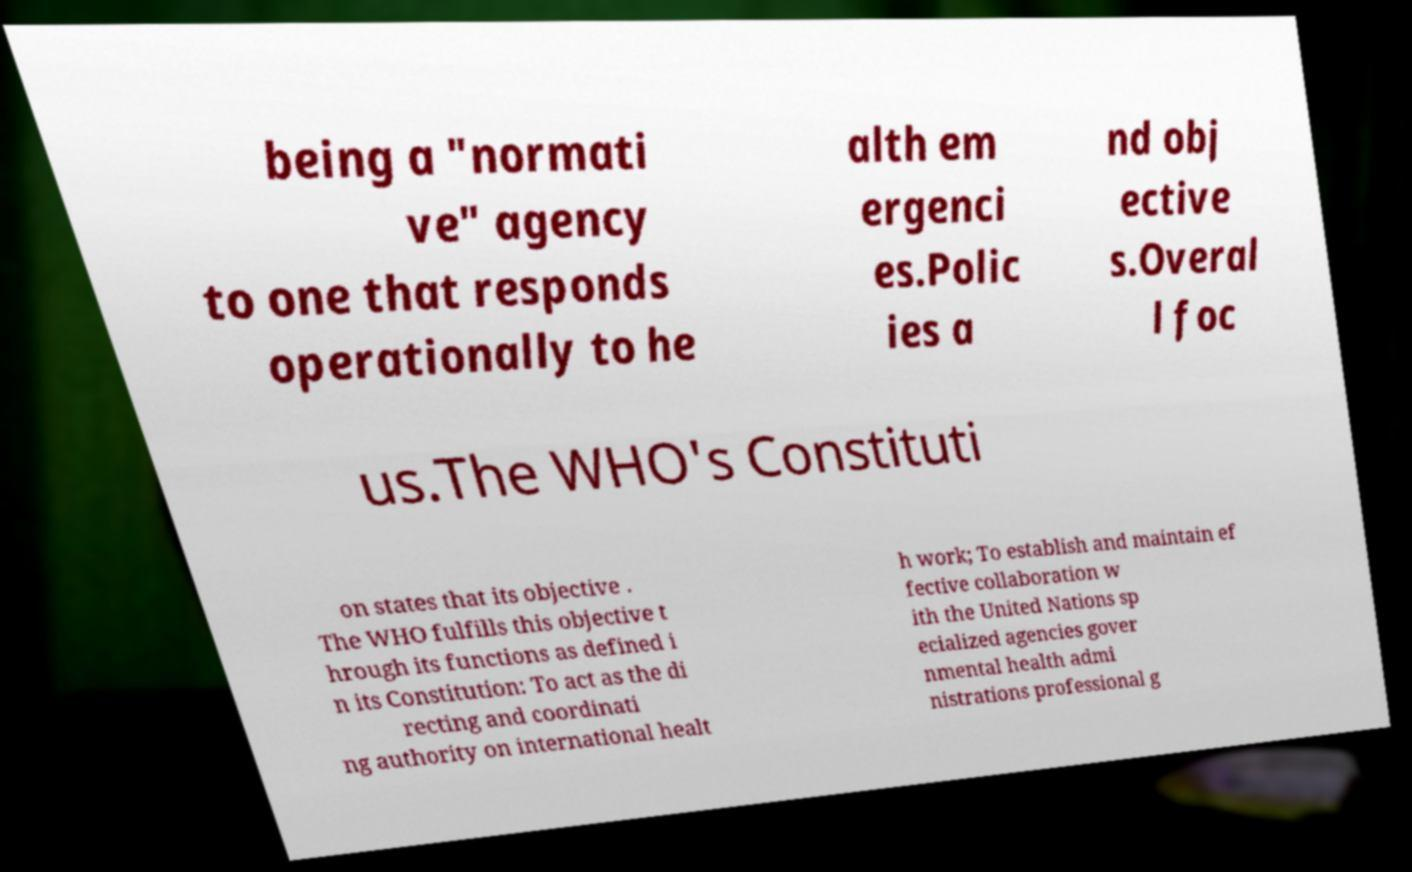For documentation purposes, I need the text within this image transcribed. Could you provide that? being a "normati ve" agency to one that responds operationally to he alth em ergenci es.Polic ies a nd obj ective s.Overal l foc us.The WHO's Constituti on states that its objective . The WHO fulfills this objective t hrough its functions as defined i n its Constitution: To act as the di recting and coordinati ng authority on international healt h work; To establish and maintain ef fective collaboration w ith the United Nations sp ecialized agencies gover nmental health admi nistrations professional g 